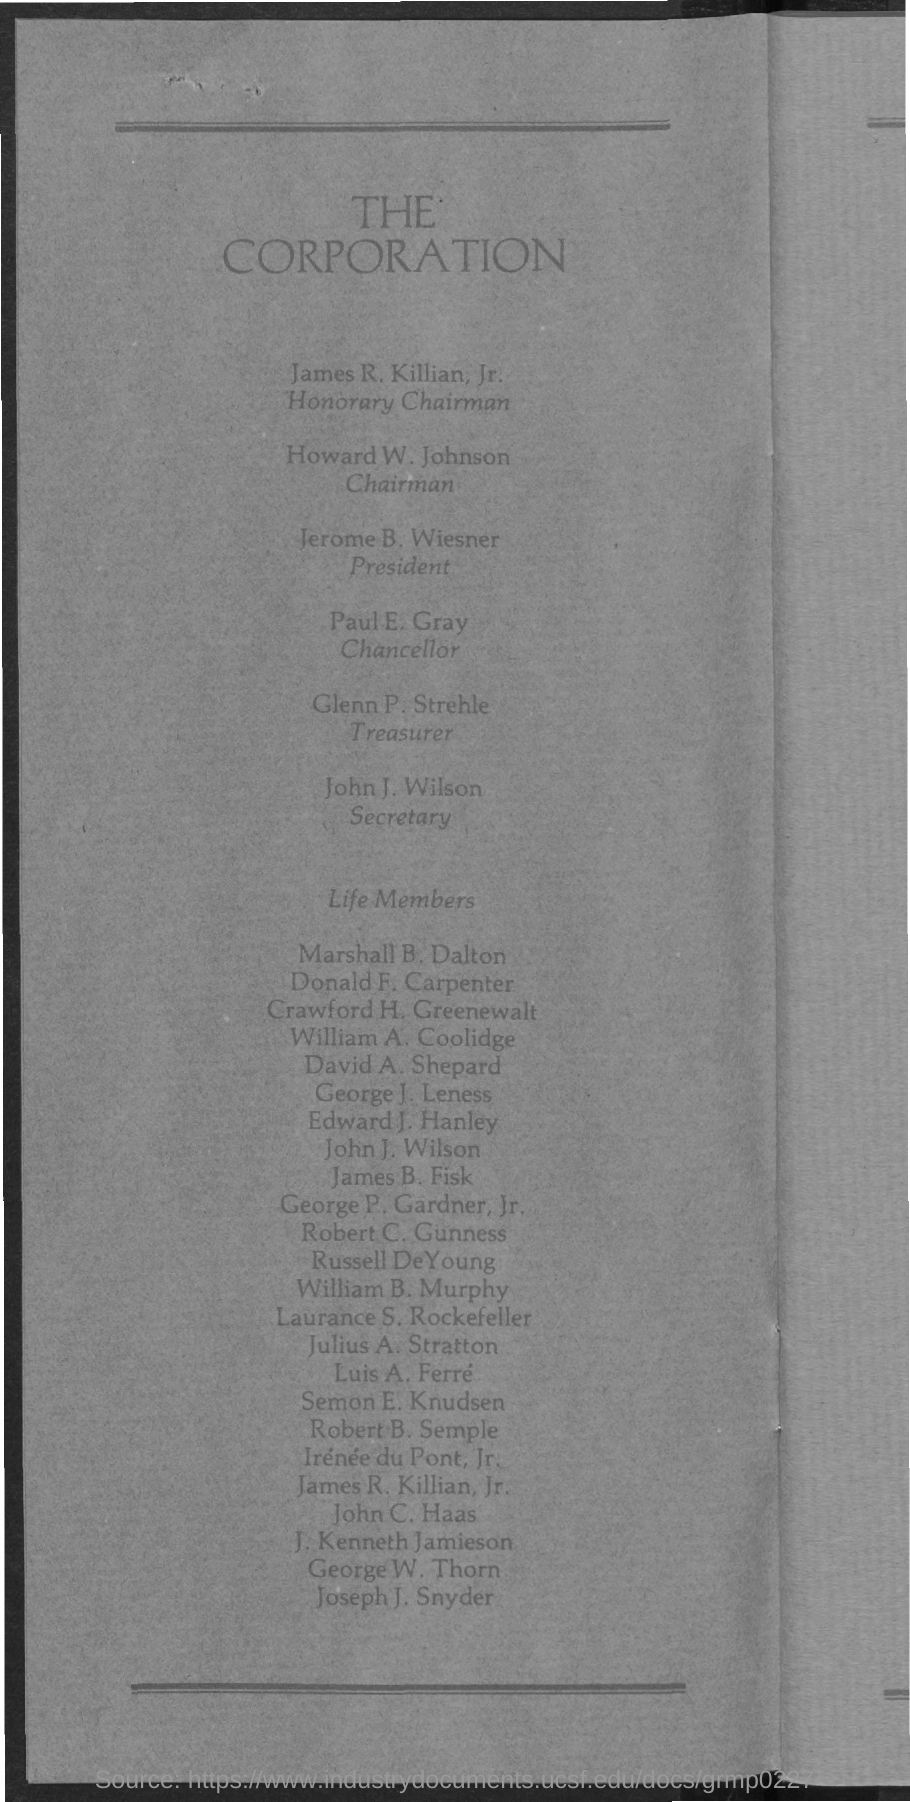Who is the Honorary Chairman?
Make the answer very short. James r. Killian, jr. Who is the Chairman?
Ensure brevity in your answer.  Howard w. Johnson. Who is the President?
Provide a succinct answer. Jerome b. wiesner. Who is the Chancellor?
Your response must be concise. Paul e. gray. Who is the Treasurer?
Provide a succinct answer. Glenn p. strehle. Who is the Secretary?
Your answer should be compact. John j. Wilson. 